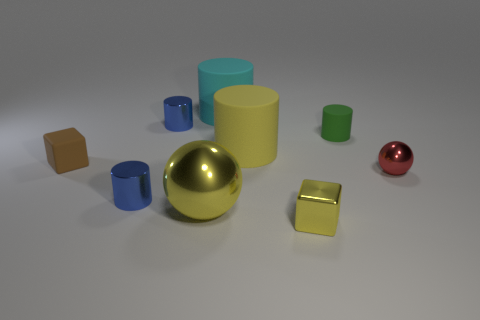Subtract all metallic cylinders. How many cylinders are left? 3 Subtract all cyan spheres. How many blue cylinders are left? 2 Subtract all yellow cylinders. How many cylinders are left? 4 Add 1 big gray objects. How many objects exist? 10 Subtract all blocks. How many objects are left? 7 Subtract all blue cylinders. Subtract all blue cubes. How many cylinders are left? 3 Add 4 tiny balls. How many tiny balls are left? 5 Add 8 green matte objects. How many green matte objects exist? 9 Subtract 2 blue cylinders. How many objects are left? 7 Subtract all balls. Subtract all tiny green rubber objects. How many objects are left? 6 